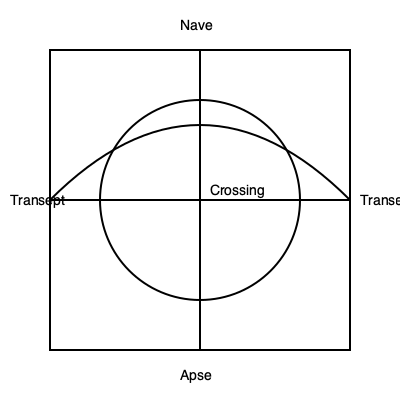In this floor plan of a cathedral, which architectural feature is represented by the semicircular area at the eastern end (bottom of the diagram)? To answer this question, let's examine the floor plan of the cathedral step-by-step:

1. The diagram shows a classic cruciform (cross-shaped) layout typical of many Christian cathedrals.

2. The long rectangular area running from left to right (west to east in traditional cathedral orientation) is the nave, where the congregation gathers.

3. The horizontal bar of the cross forms the transepts, which extend north and south.

4. At the intersection of the nave and transepts is the crossing, often surmounted by a dome or tower in many cathedrals.

5. At the eastern end (bottom of the diagram), we see a semicircular area. This semicircular termination is a distinctive feature in cathedral architecture.

6. This semicircular area is called the apse. It's typically located at the east end of the church, behind the altar, and often houses the choir or sanctuary.

The apse is an important liturgical and architectural element in Christian churches, particularly in medieval cathedrals. Its semicircular shape is derived from Roman basilicas and symbolizes the heavenly realm in Christian iconography.
Answer: Apse 